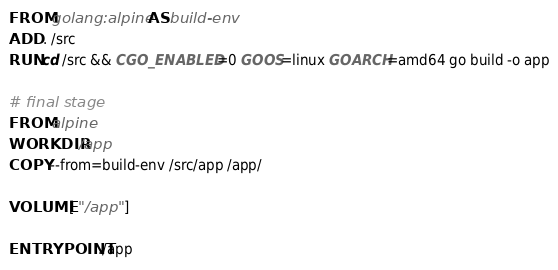<code> <loc_0><loc_0><loc_500><loc_500><_Dockerfile_>FROM golang:alpine AS build-env
ADD . /src
RUN cd /src && CGO_ENABLED=0 GOOS=linux GOARCH=amd64 go build -o app

# final stage
FROM alpine
WORKDIR /app
COPY --from=build-env /src/app /app/

VOLUME [ "/app" ]

ENTRYPOINT ./app</code> 